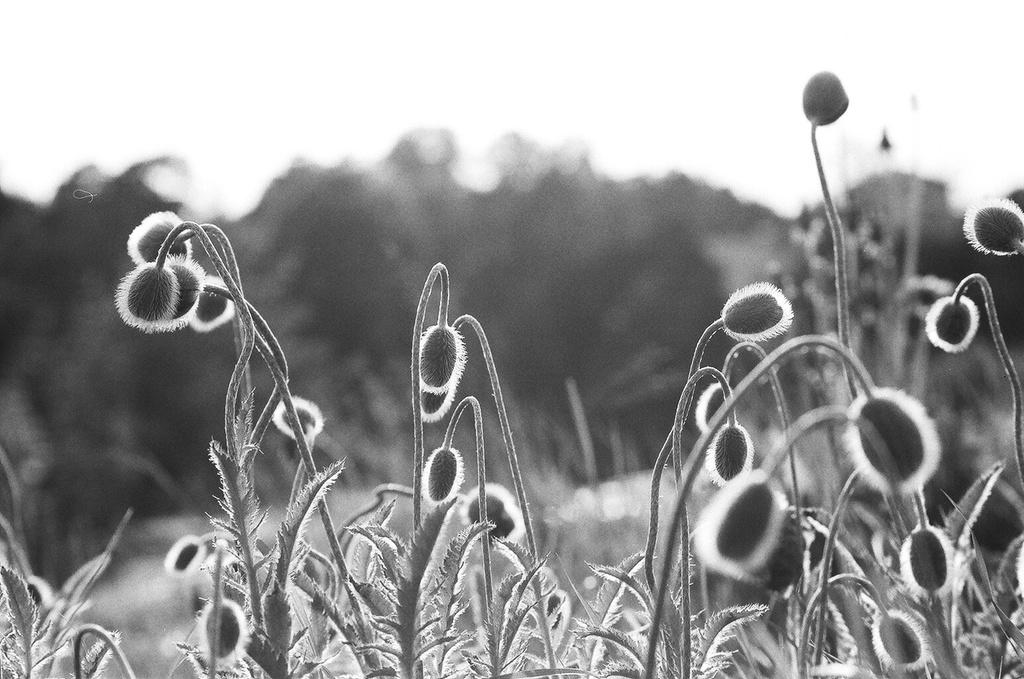What is the color scheme of the image? The image is black and white and white. What type of objects can be seen in the image? There are plants in the image. Can you describe the background of the image? The background of the image is blurred. What type of government is depicted in the image? There is no government depicted in the image; it features plants and a blurred background. What role does the farmer play in the image? There is no farmer present in the image. 